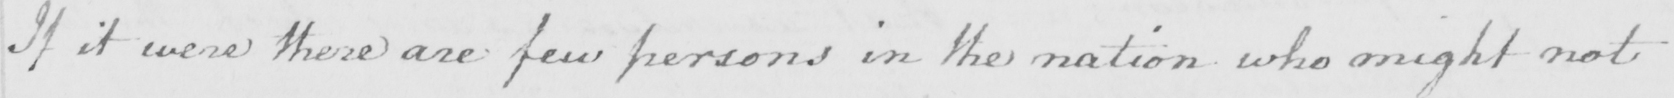Can you tell me what this handwritten text says? If it were there are few persons in the nation who might not 